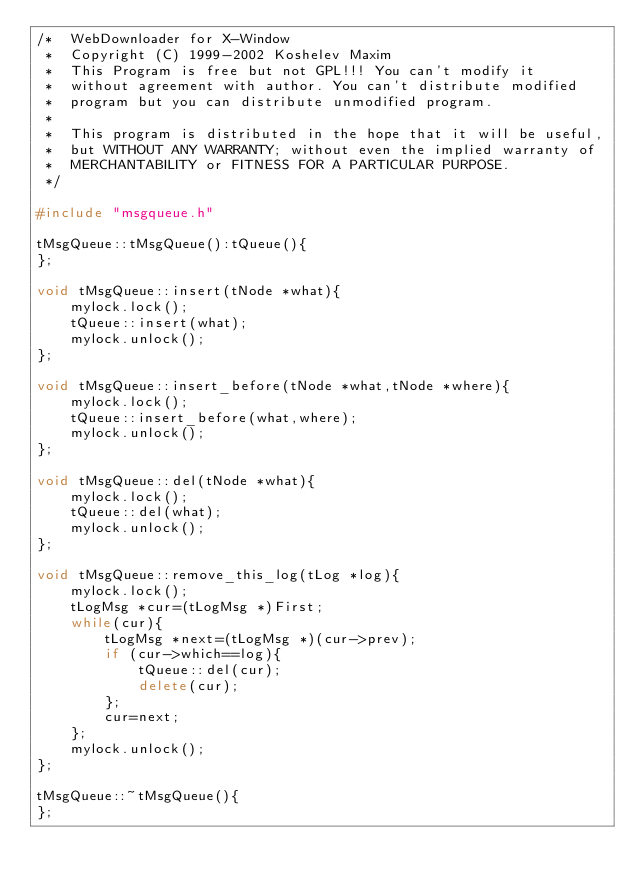<code> <loc_0><loc_0><loc_500><loc_500><_C++_>/*	WebDownloader for X-Window
 *	Copyright (C) 1999-2002 Koshelev Maxim
 *	This Program is free but not GPL!!! You can't modify it
 *	without agreement with author. You can't distribute modified
 *	program but you can distribute unmodified program.
 *
 *	This program is distributed in the hope that it will be useful,
 *	but WITHOUT ANY WARRANTY; without even the implied warranty of
 *	MERCHANTABILITY or FITNESS FOR A PARTICULAR PURPOSE.
 */

#include "msgqueue.h"

tMsgQueue::tMsgQueue():tQueue(){
};

void tMsgQueue::insert(tNode *what){
	mylock.lock();
	tQueue::insert(what);
	mylock.unlock();
};

void tMsgQueue::insert_before(tNode *what,tNode *where){
	mylock.lock();
	tQueue::insert_before(what,where);
	mylock.unlock();
};

void tMsgQueue::del(tNode *what){
	mylock.lock();
	tQueue::del(what);
	mylock.unlock();
};

void tMsgQueue::remove_this_log(tLog *log){
	mylock.lock();
	tLogMsg *cur=(tLogMsg *)First;
	while(cur){
		tLogMsg *next=(tLogMsg *)(cur->prev);
		if (cur->which==log){
			tQueue::del(cur);
			delete(cur);
		};
		cur=next;
	};
	mylock.unlock();
};

tMsgQueue::~tMsgQueue(){
};
</code> 